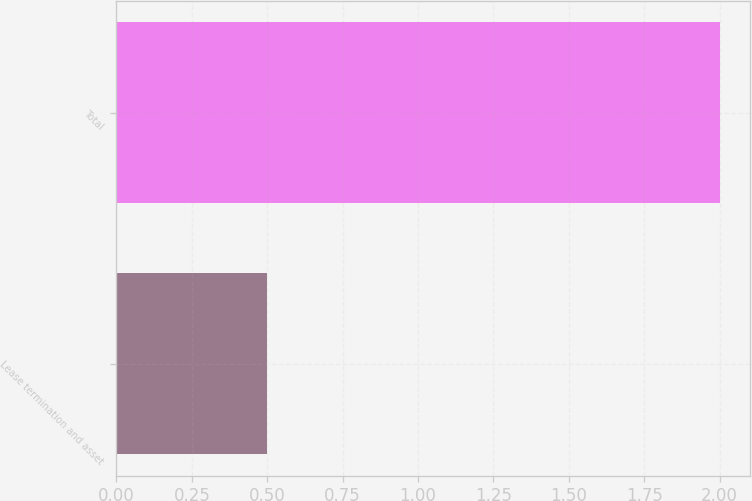<chart> <loc_0><loc_0><loc_500><loc_500><bar_chart><fcel>Lease termination and asset<fcel>Total<nl><fcel>0.5<fcel>2<nl></chart> 